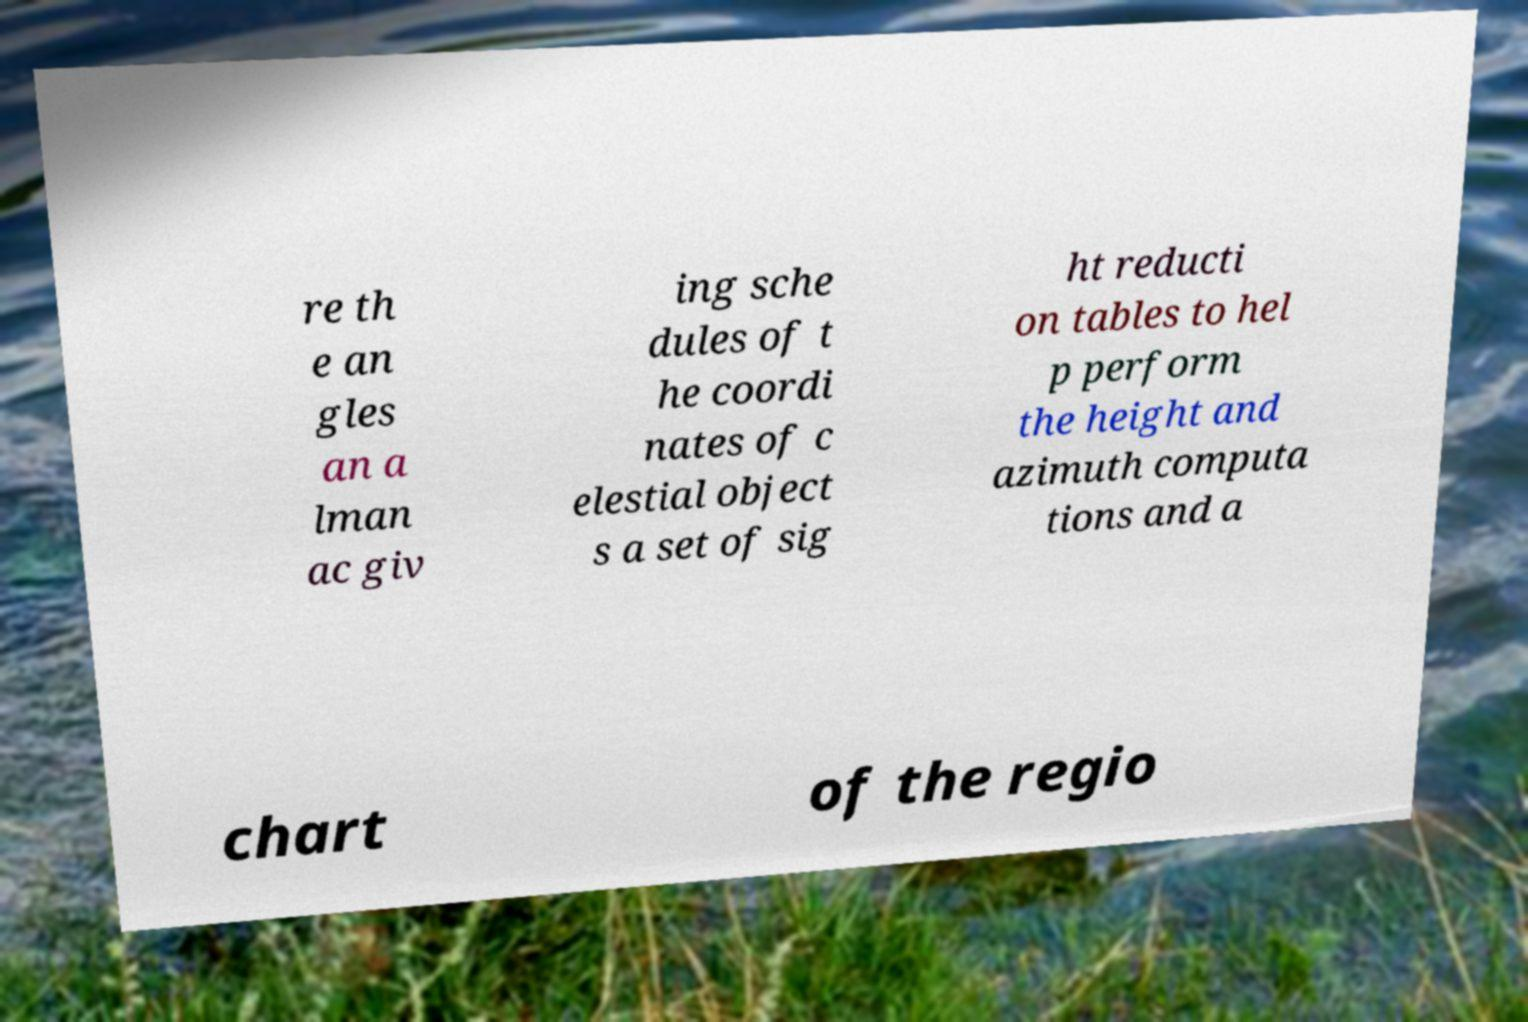Can you read and provide the text displayed in the image?This photo seems to have some interesting text. Can you extract and type it out for me? re th e an gles an a lman ac giv ing sche dules of t he coordi nates of c elestial object s a set of sig ht reducti on tables to hel p perform the height and azimuth computa tions and a chart of the regio 